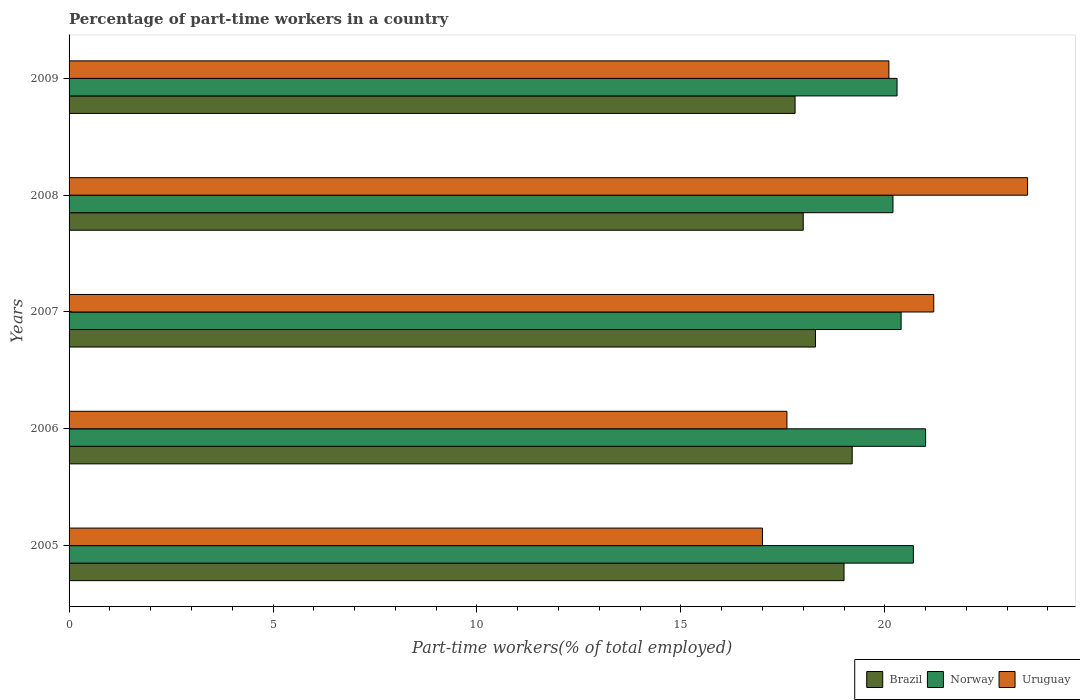How many different coloured bars are there?
Keep it short and to the point. 3. Are the number of bars per tick equal to the number of legend labels?
Provide a short and direct response. Yes. How many bars are there on the 3rd tick from the bottom?
Offer a very short reply. 3. What is the label of the 3rd group of bars from the top?
Offer a very short reply. 2007. In how many cases, is the number of bars for a given year not equal to the number of legend labels?
Give a very brief answer. 0. What is the percentage of part-time workers in Norway in 2009?
Your answer should be compact. 20.3. Across all years, what is the maximum percentage of part-time workers in Uruguay?
Offer a terse response. 23.5. Across all years, what is the minimum percentage of part-time workers in Brazil?
Your answer should be compact. 17.8. In which year was the percentage of part-time workers in Norway maximum?
Provide a short and direct response. 2006. What is the total percentage of part-time workers in Brazil in the graph?
Your answer should be very brief. 92.3. What is the difference between the percentage of part-time workers in Norway in 2007 and that in 2009?
Offer a very short reply. 0.1. What is the average percentage of part-time workers in Uruguay per year?
Offer a terse response. 19.88. In the year 2008, what is the difference between the percentage of part-time workers in Brazil and percentage of part-time workers in Norway?
Provide a short and direct response. -2.2. What is the ratio of the percentage of part-time workers in Uruguay in 2008 to that in 2009?
Make the answer very short. 1.17. What is the difference between the highest and the second highest percentage of part-time workers in Uruguay?
Your response must be concise. 2.3. What is the difference between the highest and the lowest percentage of part-time workers in Uruguay?
Make the answer very short. 6.5. In how many years, is the percentage of part-time workers in Brazil greater than the average percentage of part-time workers in Brazil taken over all years?
Your answer should be very brief. 2. Is the sum of the percentage of part-time workers in Uruguay in 2005 and 2007 greater than the maximum percentage of part-time workers in Norway across all years?
Ensure brevity in your answer.  Yes. What does the 3rd bar from the bottom in 2007 represents?
Make the answer very short. Uruguay. Is it the case that in every year, the sum of the percentage of part-time workers in Norway and percentage of part-time workers in Uruguay is greater than the percentage of part-time workers in Brazil?
Your response must be concise. Yes. How many bars are there?
Your answer should be compact. 15. Are all the bars in the graph horizontal?
Give a very brief answer. Yes. Does the graph contain any zero values?
Make the answer very short. No. Does the graph contain grids?
Provide a succinct answer. No. Where does the legend appear in the graph?
Your answer should be compact. Bottom right. How are the legend labels stacked?
Offer a terse response. Horizontal. What is the title of the graph?
Your answer should be compact. Percentage of part-time workers in a country. Does "World" appear as one of the legend labels in the graph?
Offer a terse response. No. What is the label or title of the X-axis?
Your answer should be very brief. Part-time workers(% of total employed). What is the Part-time workers(% of total employed) of Norway in 2005?
Offer a very short reply. 20.7. What is the Part-time workers(% of total employed) of Brazil in 2006?
Provide a short and direct response. 19.2. What is the Part-time workers(% of total employed) of Uruguay in 2006?
Make the answer very short. 17.6. What is the Part-time workers(% of total employed) in Brazil in 2007?
Your response must be concise. 18.3. What is the Part-time workers(% of total employed) in Norway in 2007?
Your response must be concise. 20.4. What is the Part-time workers(% of total employed) in Uruguay in 2007?
Your answer should be very brief. 21.2. What is the Part-time workers(% of total employed) of Norway in 2008?
Keep it short and to the point. 20.2. What is the Part-time workers(% of total employed) of Brazil in 2009?
Give a very brief answer. 17.8. What is the Part-time workers(% of total employed) in Norway in 2009?
Offer a terse response. 20.3. What is the Part-time workers(% of total employed) of Uruguay in 2009?
Make the answer very short. 20.1. Across all years, what is the maximum Part-time workers(% of total employed) of Brazil?
Provide a short and direct response. 19.2. Across all years, what is the minimum Part-time workers(% of total employed) of Brazil?
Offer a very short reply. 17.8. Across all years, what is the minimum Part-time workers(% of total employed) of Norway?
Keep it short and to the point. 20.2. What is the total Part-time workers(% of total employed) of Brazil in the graph?
Your answer should be compact. 92.3. What is the total Part-time workers(% of total employed) of Norway in the graph?
Ensure brevity in your answer.  102.6. What is the total Part-time workers(% of total employed) of Uruguay in the graph?
Ensure brevity in your answer.  99.4. What is the difference between the Part-time workers(% of total employed) of Brazil in 2005 and that in 2006?
Keep it short and to the point. -0.2. What is the difference between the Part-time workers(% of total employed) of Brazil in 2005 and that in 2007?
Provide a succinct answer. 0.7. What is the difference between the Part-time workers(% of total employed) in Norway in 2005 and that in 2007?
Make the answer very short. 0.3. What is the difference between the Part-time workers(% of total employed) of Brazil in 2005 and that in 2008?
Offer a terse response. 1. What is the difference between the Part-time workers(% of total employed) of Norway in 2005 and that in 2008?
Your response must be concise. 0.5. What is the difference between the Part-time workers(% of total employed) in Uruguay in 2005 and that in 2008?
Make the answer very short. -6.5. What is the difference between the Part-time workers(% of total employed) in Norway in 2005 and that in 2009?
Provide a short and direct response. 0.4. What is the difference between the Part-time workers(% of total employed) in Uruguay in 2005 and that in 2009?
Provide a succinct answer. -3.1. What is the difference between the Part-time workers(% of total employed) of Norway in 2006 and that in 2007?
Make the answer very short. 0.6. What is the difference between the Part-time workers(% of total employed) of Uruguay in 2006 and that in 2008?
Offer a terse response. -5.9. What is the difference between the Part-time workers(% of total employed) in Brazil in 2006 and that in 2009?
Your answer should be very brief. 1.4. What is the difference between the Part-time workers(% of total employed) of Norway in 2006 and that in 2009?
Your response must be concise. 0.7. What is the difference between the Part-time workers(% of total employed) of Uruguay in 2006 and that in 2009?
Your response must be concise. -2.5. What is the difference between the Part-time workers(% of total employed) in Brazil in 2007 and that in 2008?
Keep it short and to the point. 0.3. What is the difference between the Part-time workers(% of total employed) of Brazil in 2007 and that in 2009?
Offer a terse response. 0.5. What is the difference between the Part-time workers(% of total employed) in Norway in 2007 and that in 2009?
Your answer should be compact. 0.1. What is the difference between the Part-time workers(% of total employed) in Brazil in 2008 and that in 2009?
Provide a succinct answer. 0.2. What is the difference between the Part-time workers(% of total employed) in Uruguay in 2008 and that in 2009?
Ensure brevity in your answer.  3.4. What is the difference between the Part-time workers(% of total employed) in Brazil in 2005 and the Part-time workers(% of total employed) in Norway in 2006?
Your answer should be very brief. -2. What is the difference between the Part-time workers(% of total employed) of Norway in 2005 and the Part-time workers(% of total employed) of Uruguay in 2006?
Offer a terse response. 3.1. What is the difference between the Part-time workers(% of total employed) in Brazil in 2005 and the Part-time workers(% of total employed) in Uruguay in 2007?
Your answer should be very brief. -2.2. What is the difference between the Part-time workers(% of total employed) in Norway in 2005 and the Part-time workers(% of total employed) in Uruguay in 2007?
Provide a succinct answer. -0.5. What is the difference between the Part-time workers(% of total employed) of Brazil in 2005 and the Part-time workers(% of total employed) of Uruguay in 2009?
Give a very brief answer. -1.1. What is the difference between the Part-time workers(% of total employed) in Brazil in 2006 and the Part-time workers(% of total employed) in Uruguay in 2007?
Provide a short and direct response. -2. What is the difference between the Part-time workers(% of total employed) in Norway in 2006 and the Part-time workers(% of total employed) in Uruguay in 2007?
Your answer should be compact. -0.2. What is the difference between the Part-time workers(% of total employed) of Brazil in 2006 and the Part-time workers(% of total employed) of Uruguay in 2008?
Your answer should be very brief. -4.3. What is the difference between the Part-time workers(% of total employed) in Norway in 2006 and the Part-time workers(% of total employed) in Uruguay in 2009?
Your answer should be very brief. 0.9. What is the difference between the Part-time workers(% of total employed) of Brazil in 2007 and the Part-time workers(% of total employed) of Norway in 2008?
Provide a short and direct response. -1.9. What is the difference between the Part-time workers(% of total employed) of Brazil in 2007 and the Part-time workers(% of total employed) of Uruguay in 2008?
Offer a terse response. -5.2. What is the difference between the Part-time workers(% of total employed) in Norway in 2007 and the Part-time workers(% of total employed) in Uruguay in 2008?
Offer a very short reply. -3.1. What is the difference between the Part-time workers(% of total employed) of Brazil in 2007 and the Part-time workers(% of total employed) of Norway in 2009?
Make the answer very short. -2. What is the average Part-time workers(% of total employed) of Brazil per year?
Keep it short and to the point. 18.46. What is the average Part-time workers(% of total employed) in Norway per year?
Provide a succinct answer. 20.52. What is the average Part-time workers(% of total employed) of Uruguay per year?
Offer a very short reply. 19.88. In the year 2005, what is the difference between the Part-time workers(% of total employed) in Brazil and Part-time workers(% of total employed) in Uruguay?
Give a very brief answer. 2. In the year 2005, what is the difference between the Part-time workers(% of total employed) in Norway and Part-time workers(% of total employed) in Uruguay?
Provide a succinct answer. 3.7. In the year 2007, what is the difference between the Part-time workers(% of total employed) in Brazil and Part-time workers(% of total employed) in Norway?
Offer a very short reply. -2.1. In the year 2007, what is the difference between the Part-time workers(% of total employed) of Brazil and Part-time workers(% of total employed) of Uruguay?
Give a very brief answer. -2.9. In the year 2008, what is the difference between the Part-time workers(% of total employed) in Norway and Part-time workers(% of total employed) in Uruguay?
Provide a short and direct response. -3.3. What is the ratio of the Part-time workers(% of total employed) of Brazil in 2005 to that in 2006?
Make the answer very short. 0.99. What is the ratio of the Part-time workers(% of total employed) in Norway in 2005 to that in 2006?
Provide a short and direct response. 0.99. What is the ratio of the Part-time workers(% of total employed) in Uruguay in 2005 to that in 2006?
Offer a terse response. 0.97. What is the ratio of the Part-time workers(% of total employed) in Brazil in 2005 to that in 2007?
Give a very brief answer. 1.04. What is the ratio of the Part-time workers(% of total employed) in Norway in 2005 to that in 2007?
Offer a very short reply. 1.01. What is the ratio of the Part-time workers(% of total employed) in Uruguay in 2005 to that in 2007?
Provide a short and direct response. 0.8. What is the ratio of the Part-time workers(% of total employed) of Brazil in 2005 to that in 2008?
Your response must be concise. 1.06. What is the ratio of the Part-time workers(% of total employed) of Norway in 2005 to that in 2008?
Offer a terse response. 1.02. What is the ratio of the Part-time workers(% of total employed) of Uruguay in 2005 to that in 2008?
Ensure brevity in your answer.  0.72. What is the ratio of the Part-time workers(% of total employed) in Brazil in 2005 to that in 2009?
Give a very brief answer. 1.07. What is the ratio of the Part-time workers(% of total employed) of Norway in 2005 to that in 2009?
Ensure brevity in your answer.  1.02. What is the ratio of the Part-time workers(% of total employed) of Uruguay in 2005 to that in 2009?
Your answer should be compact. 0.85. What is the ratio of the Part-time workers(% of total employed) of Brazil in 2006 to that in 2007?
Your response must be concise. 1.05. What is the ratio of the Part-time workers(% of total employed) in Norway in 2006 to that in 2007?
Keep it short and to the point. 1.03. What is the ratio of the Part-time workers(% of total employed) in Uruguay in 2006 to that in 2007?
Offer a very short reply. 0.83. What is the ratio of the Part-time workers(% of total employed) of Brazil in 2006 to that in 2008?
Keep it short and to the point. 1.07. What is the ratio of the Part-time workers(% of total employed) of Norway in 2006 to that in 2008?
Your response must be concise. 1.04. What is the ratio of the Part-time workers(% of total employed) of Uruguay in 2006 to that in 2008?
Provide a short and direct response. 0.75. What is the ratio of the Part-time workers(% of total employed) of Brazil in 2006 to that in 2009?
Ensure brevity in your answer.  1.08. What is the ratio of the Part-time workers(% of total employed) of Norway in 2006 to that in 2009?
Offer a terse response. 1.03. What is the ratio of the Part-time workers(% of total employed) in Uruguay in 2006 to that in 2009?
Your answer should be compact. 0.88. What is the ratio of the Part-time workers(% of total employed) in Brazil in 2007 to that in 2008?
Your answer should be very brief. 1.02. What is the ratio of the Part-time workers(% of total employed) of Norway in 2007 to that in 2008?
Your answer should be compact. 1.01. What is the ratio of the Part-time workers(% of total employed) of Uruguay in 2007 to that in 2008?
Your response must be concise. 0.9. What is the ratio of the Part-time workers(% of total employed) of Brazil in 2007 to that in 2009?
Offer a very short reply. 1.03. What is the ratio of the Part-time workers(% of total employed) of Norway in 2007 to that in 2009?
Ensure brevity in your answer.  1. What is the ratio of the Part-time workers(% of total employed) of Uruguay in 2007 to that in 2009?
Give a very brief answer. 1.05. What is the ratio of the Part-time workers(% of total employed) of Brazil in 2008 to that in 2009?
Make the answer very short. 1.01. What is the ratio of the Part-time workers(% of total employed) of Norway in 2008 to that in 2009?
Your answer should be compact. 1. What is the ratio of the Part-time workers(% of total employed) in Uruguay in 2008 to that in 2009?
Offer a very short reply. 1.17. What is the difference between the highest and the second highest Part-time workers(% of total employed) in Norway?
Make the answer very short. 0.3. What is the difference between the highest and the lowest Part-time workers(% of total employed) of Uruguay?
Offer a terse response. 6.5. 